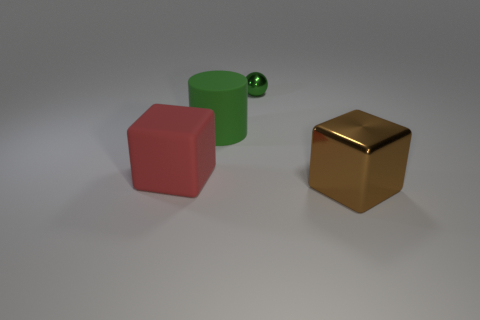Add 4 gray matte cylinders. How many objects exist? 8 Subtract 1 cylinders. How many cylinders are left? 0 Subtract all big red blocks. Subtract all large rubber cylinders. How many objects are left? 2 Add 4 red blocks. How many red blocks are left? 5 Add 1 big purple metallic blocks. How many big purple metallic blocks exist? 1 Subtract 0 purple cylinders. How many objects are left? 4 Subtract all purple cylinders. Subtract all gray cubes. How many cylinders are left? 1 